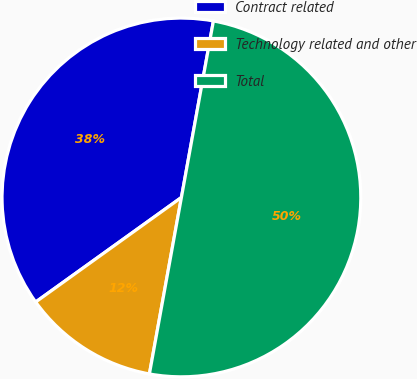Convert chart to OTSL. <chart><loc_0><loc_0><loc_500><loc_500><pie_chart><fcel>Contract related<fcel>Technology related and other<fcel>Total<nl><fcel>37.76%<fcel>12.24%<fcel>50.0%<nl></chart> 